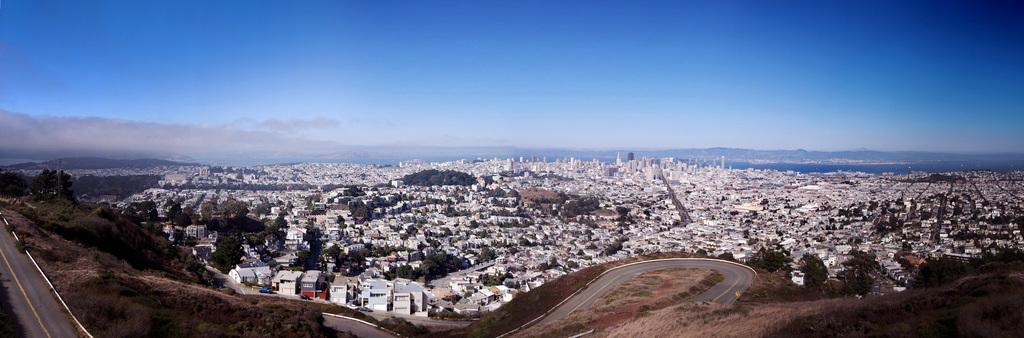Could you give a brief overview of what you see in this image? This is the top view of a city, in this image there are roads, buildings, trees, mountains and a sea, at the top of the image there are clouds in the sky. 